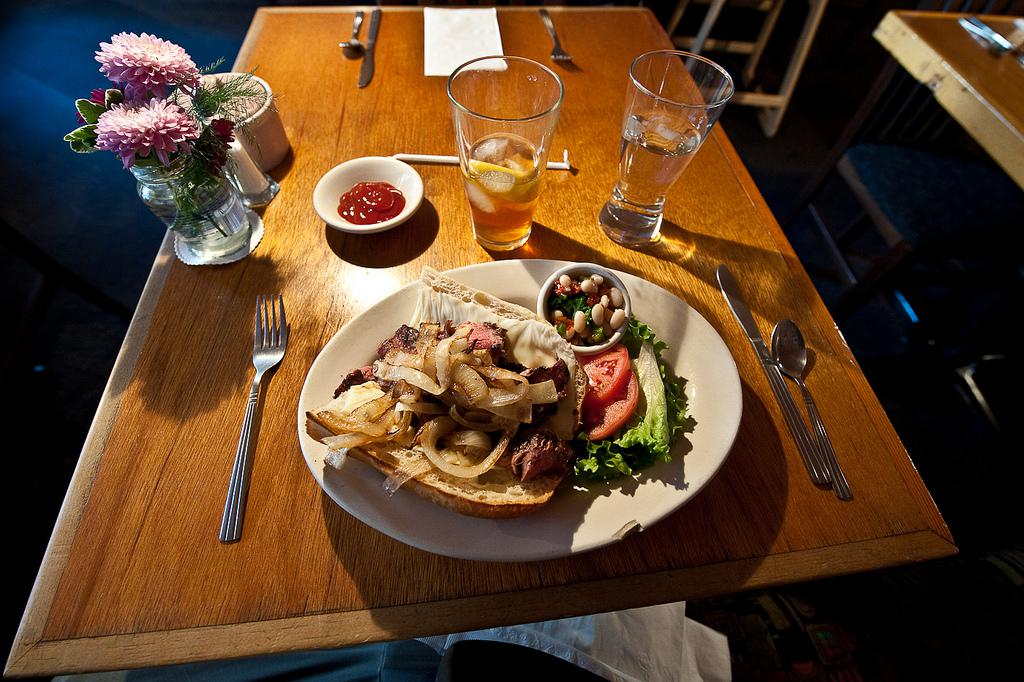Question: what is the number of flowers in the glass?
Choices:
A. A dozen.
B. Two.
C. Six.
D. Four.
Answer with the letter. Answer: B Question: what is lavender?
Choices:
A. Plant.
B. Dress.
C. Scarf.
D. Flowers.
Answer with the letter. Answer: D Question: what is on the plate?
Choices:
A. A meal.
B. Lunch.
C. A sandwich.
D. Green beans.
Answer with the letter. Answer: A Question: how many glasses are on the table?
Choices:
A. Two.
B. Three.
C. Four.
D. Five.
Answer with the letter. Answer: B Question: what is the red stuff in the small white dish?
Choices:
A. Ketchup.
B. Tomato soup.
C. Strawberry jelly.
D. Raspberry jelly.
Answer with the letter. Answer: A Question: where is a glass with two flowers?
Choices:
A. Desk.
B. Windowsill.
C. On table.
D. Restaurant.
Answer with the letter. Answer: C Question: where is the fork?
Choices:
A. To the left side of the plate.
B. On the plate.
C. To the right of the plate.
D. In the salad bowl.
Answer with the letter. Answer: A Question: where was this photo taken?
Choices:
A. In a restaurant.
B. In a stadium.
C. In a night club.
D. In a movie theater.
Answer with the letter. Answer: A Question: how many flowers are there?
Choices:
A. One.
B. Two.
C. Three.
D. None.
Answer with the letter. Answer: B Question: what is floating in a glass of amber liquid?
Choices:
A. A straw.
B. A little umbrella.
C. A reflection.
D. Ice cubes.
Answer with the letter. Answer: D Question: what sits right of the plate?
Choices:
A. Glass.
B. Napkin.
C. A knife and spoon.
D. A salad plate.
Answer with the letter. Answer: C Question: what sits on the plate?
Choices:
A. Toasted bread roll filled with steak and onions.
B. Side dishes.
C. Soup bowl.
D. Napkins.
Answer with the letter. Answer: A Question: how many glasses are on table?
Choices:
A. One.
B. Two.
C. Three.
D. Four.
Answer with the letter. Answer: B Question: what is the food item on topmost of the sandwich?
Choices:
A. Onions.
B. Meat.
C. Tomato slice.
D. Lettuce.
Answer with the letter. Answer: A Question: what are the red slices on top of the lettuce?
Choices:
A. Peppers.
B. Read Meat.
C. Apples.
D. Tomatoes.
Answer with the letter. Answer: D Question: who will eat the food?
Choices:
A. The child.
B. The woman.
C. A diner.
D. The man.
Answer with the letter. Answer: C Question: how many glasses have liquid in them?
Choices:
A. 4.
B. 6.
C. 8.
D. 2.
Answer with the letter. Answer: D 